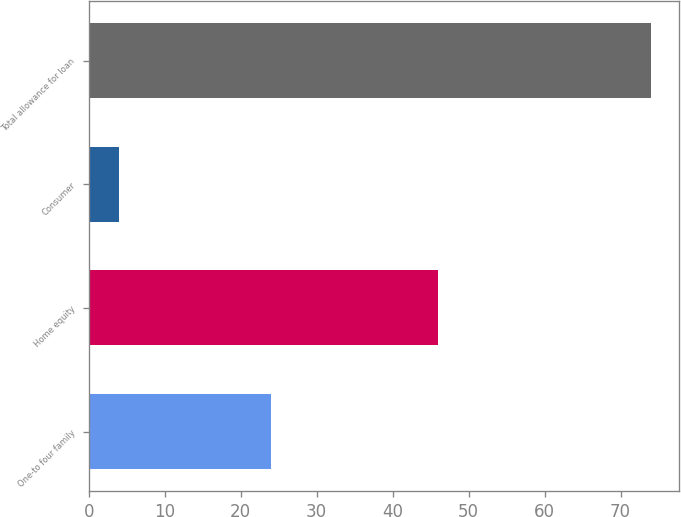<chart> <loc_0><loc_0><loc_500><loc_500><bar_chart><fcel>One-to four family<fcel>Home equity<fcel>Consumer<fcel>Total allowance for loan<nl><fcel>24<fcel>46<fcel>4<fcel>74<nl></chart> 